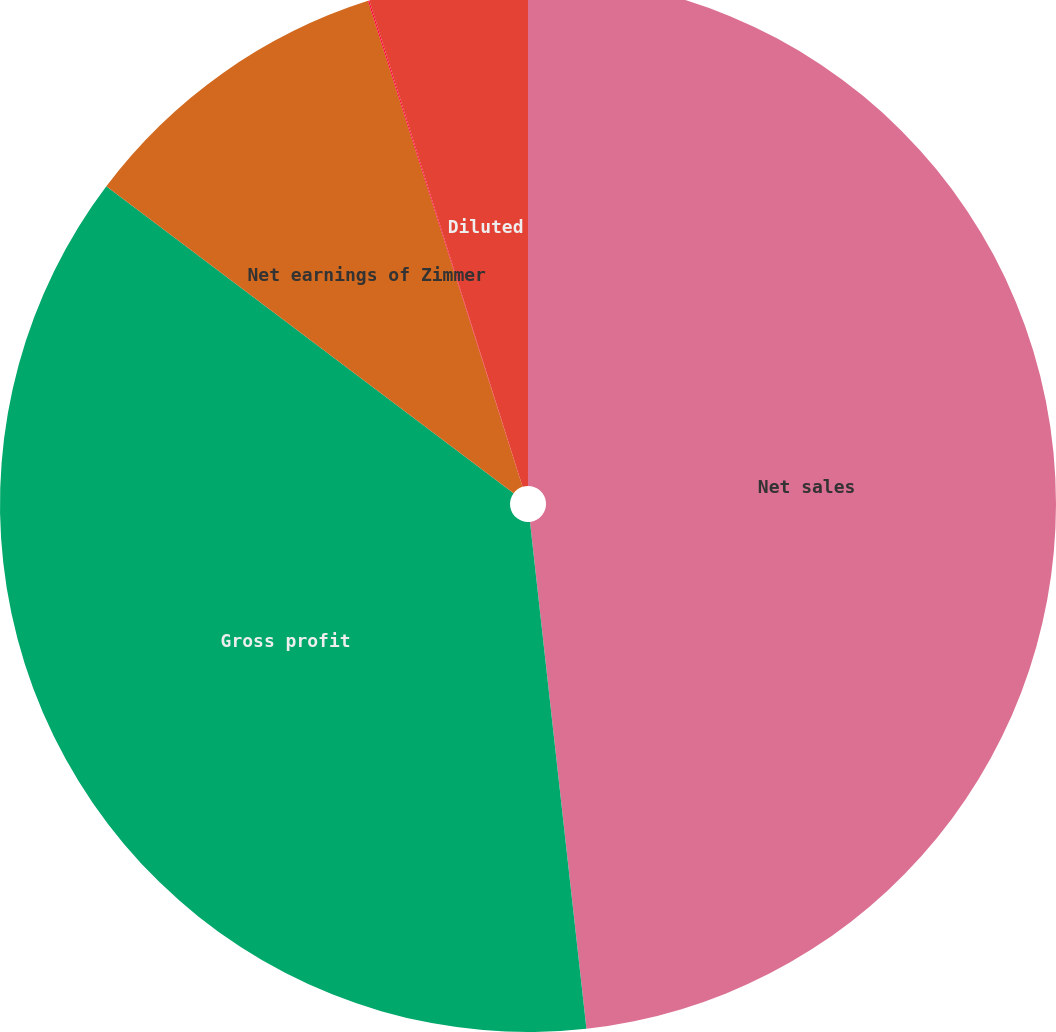<chart> <loc_0><loc_0><loc_500><loc_500><pie_chart><fcel>Net sales<fcel>Gross profit<fcel>Net earnings of Zimmer<fcel>Basic<fcel>Diluted<nl><fcel>48.23%<fcel>37.04%<fcel>9.82%<fcel>0.04%<fcel>4.86%<nl></chart> 